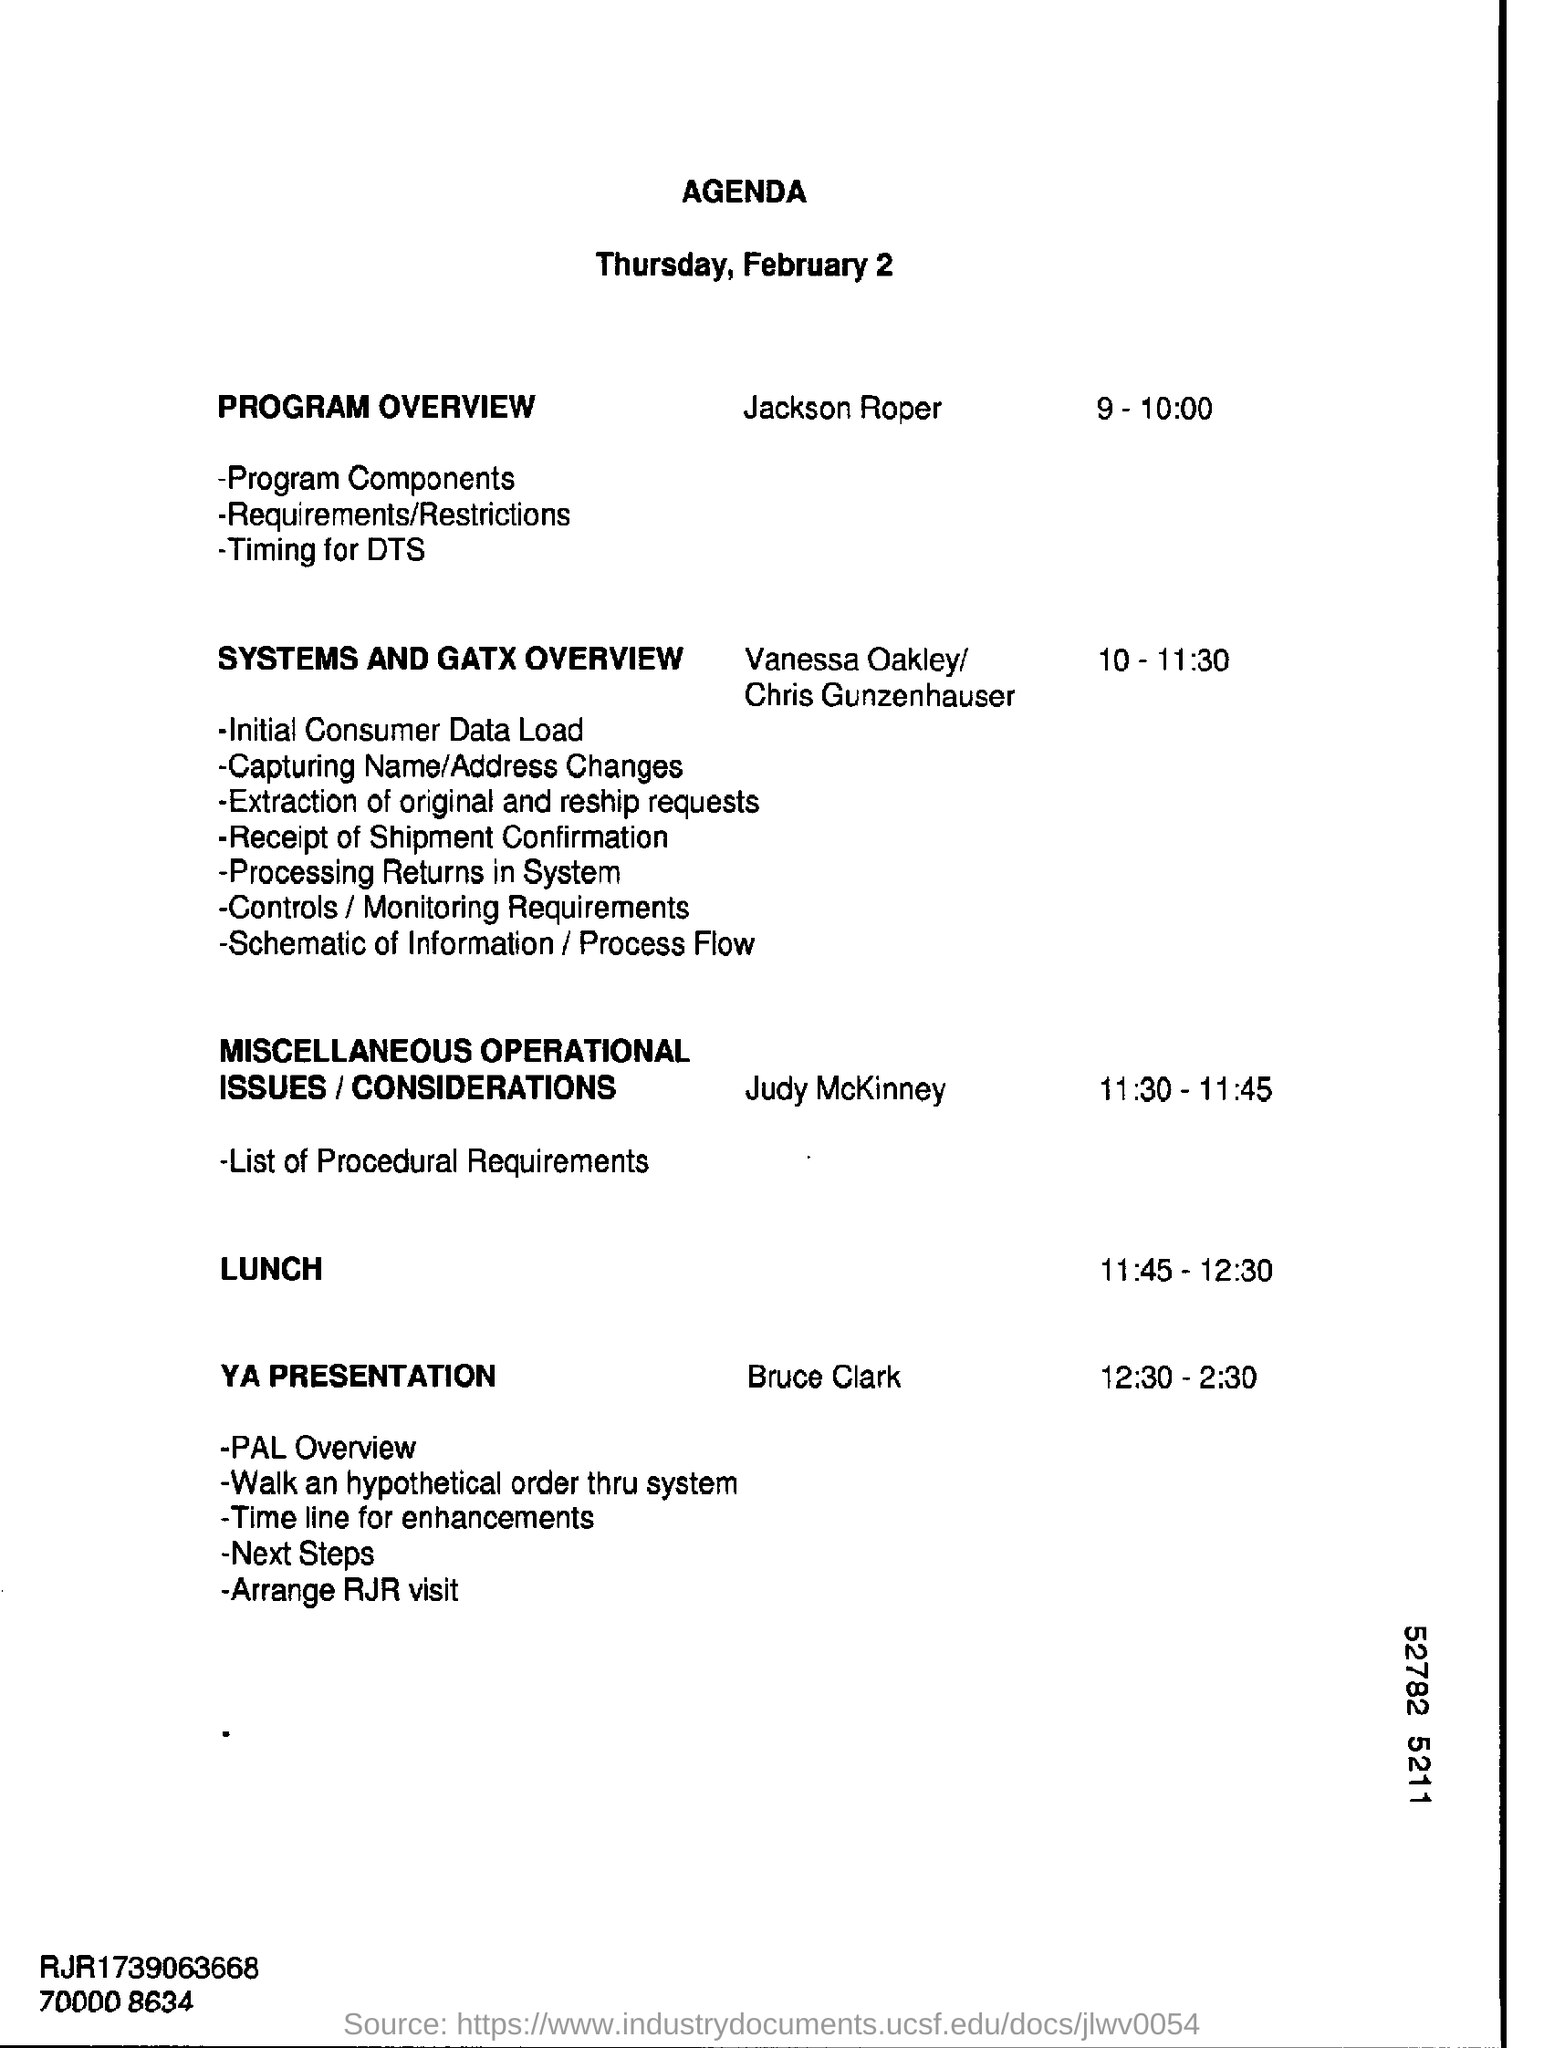Give some essential details in this illustration. The document provides information that includes a date listed as Thursday, February 2.. The title of the document is 'Agenda.' The lunch time is from 11:45 to 12:30. 